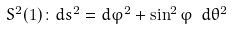Convert formula to latex. <formula><loc_0><loc_0><loc_500><loc_500>S ^ { 2 } ( 1 ) \colon d s ^ { 2 } = d \varphi ^ { 2 } + \sin ^ { 2 } \varphi \text { } d \theta ^ { 2 }</formula> 